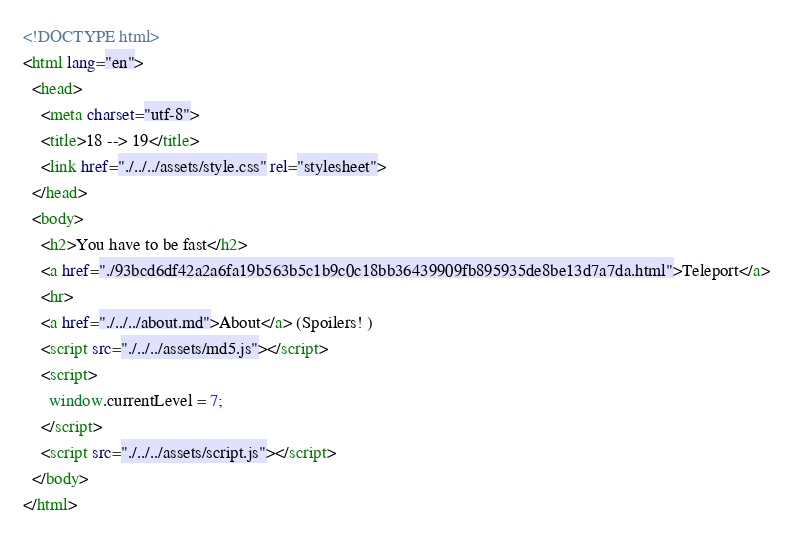Convert code to text. <code><loc_0><loc_0><loc_500><loc_500><_HTML_><!DOCTYPE html>
<html lang="en">
  <head>
    <meta charset="utf-8">
    <title>18 --> 19</title>
    <link href="./../../assets/style.css" rel="stylesheet">
  </head>
  <body>
    <h2>You have to be fast</h2>
    <a href="./93bcd6df42a2a6fa19b563b5c1b9c0c18bb36439909fb895935de8be13d7a7da.html">Teleport</a>
    <hr>
    <a href="./../../about.md">About</a> (Spoilers! )
    <script src="./../../assets/md5.js"></script>
    <script>
      window.currentLevel = 7;
    </script>
    <script src="./../../assets/script.js"></script>
  </body>
</html></code> 